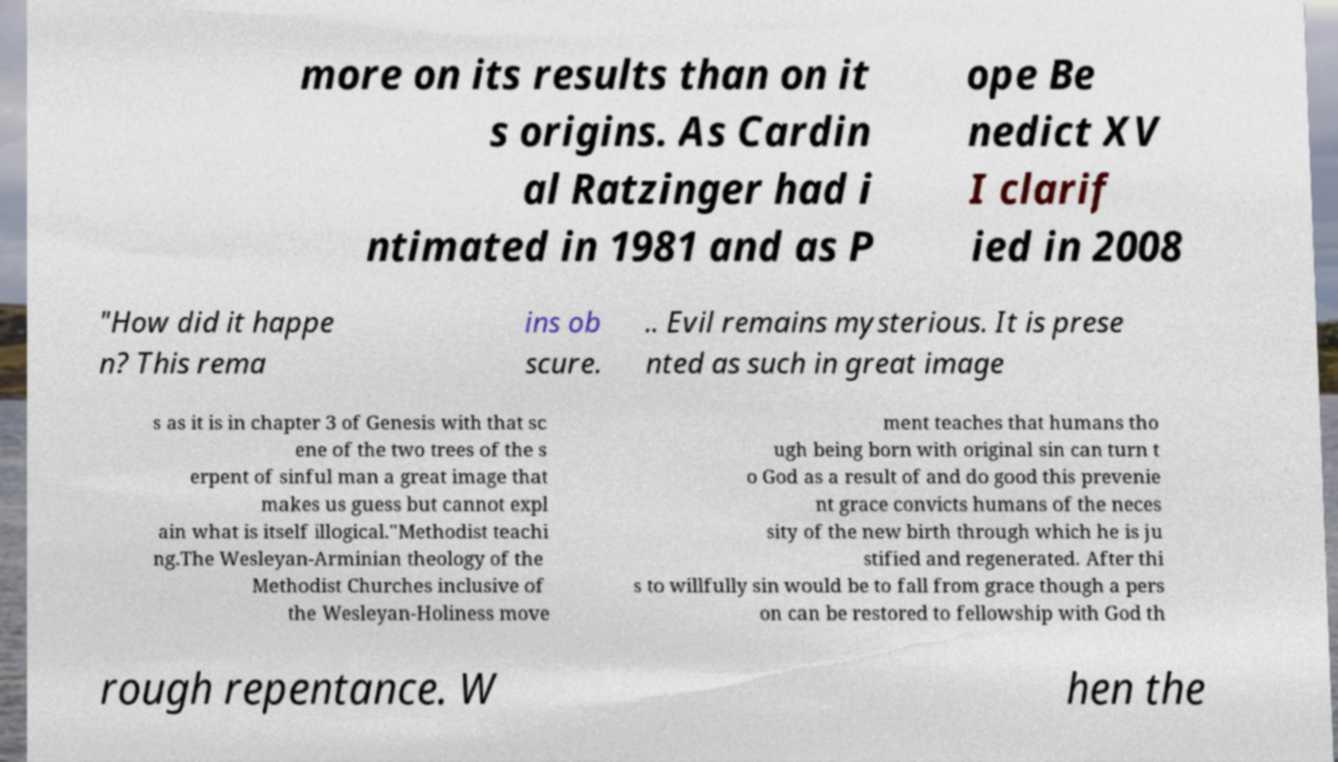Please read and relay the text visible in this image. What does it say? more on its results than on it s origins. As Cardin al Ratzinger had i ntimated in 1981 and as P ope Be nedict XV I clarif ied in 2008 "How did it happe n? This rema ins ob scure. .. Evil remains mysterious. It is prese nted as such in great image s as it is in chapter 3 of Genesis with that sc ene of the two trees of the s erpent of sinful man a great image that makes us guess but cannot expl ain what is itself illogical."Methodist teachi ng.The Wesleyan-Arminian theology of the Methodist Churches inclusive of the Wesleyan-Holiness move ment teaches that humans tho ugh being born with original sin can turn t o God as a result of and do good this prevenie nt grace convicts humans of the neces sity of the new birth through which he is ju stified and regenerated. After thi s to willfully sin would be to fall from grace though a pers on can be restored to fellowship with God th rough repentance. W hen the 